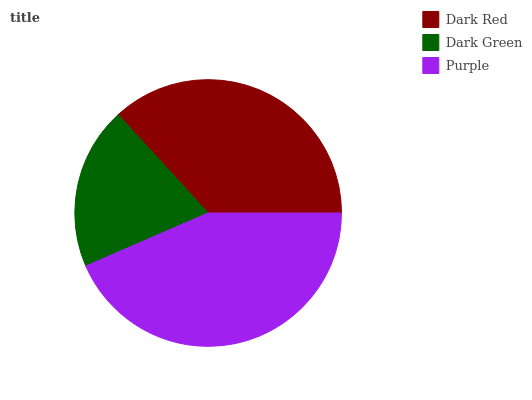Is Dark Green the minimum?
Answer yes or no. Yes. Is Purple the maximum?
Answer yes or no. Yes. Is Purple the minimum?
Answer yes or no. No. Is Dark Green the maximum?
Answer yes or no. No. Is Purple greater than Dark Green?
Answer yes or no. Yes. Is Dark Green less than Purple?
Answer yes or no. Yes. Is Dark Green greater than Purple?
Answer yes or no. No. Is Purple less than Dark Green?
Answer yes or no. No. Is Dark Red the high median?
Answer yes or no. Yes. Is Dark Red the low median?
Answer yes or no. Yes. Is Purple the high median?
Answer yes or no. No. Is Purple the low median?
Answer yes or no. No. 